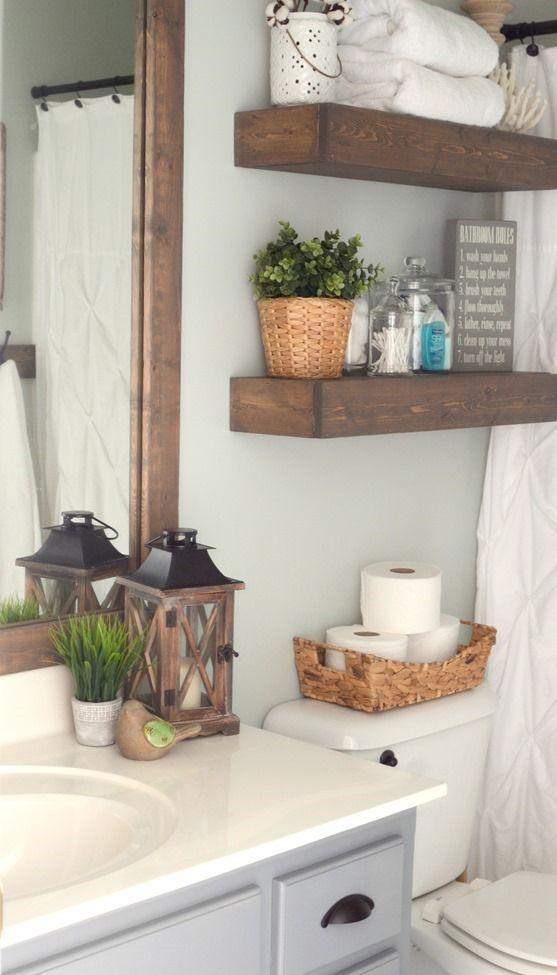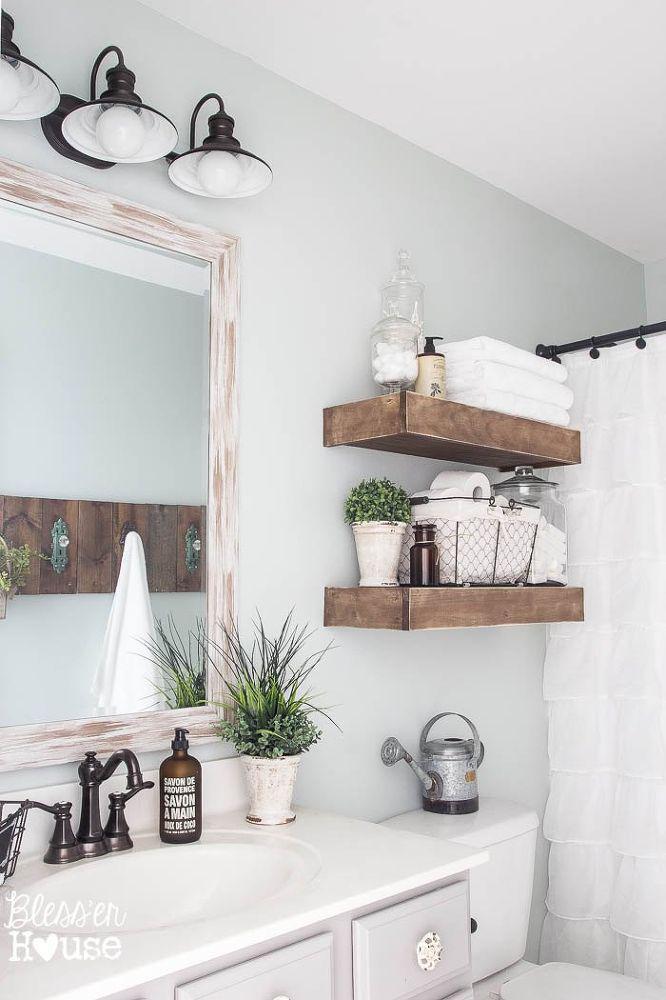The first image is the image on the left, the second image is the image on the right. Assess this claim about the two images: "There is a wooden floor visible in at least one of the images.". Correct or not? Answer yes or no. No. The first image is the image on the left, the second image is the image on the right. For the images shown, is this caption "At least one image shows floating brown shelves, and all images include at least one potted green plant." true? Answer yes or no. Yes. 